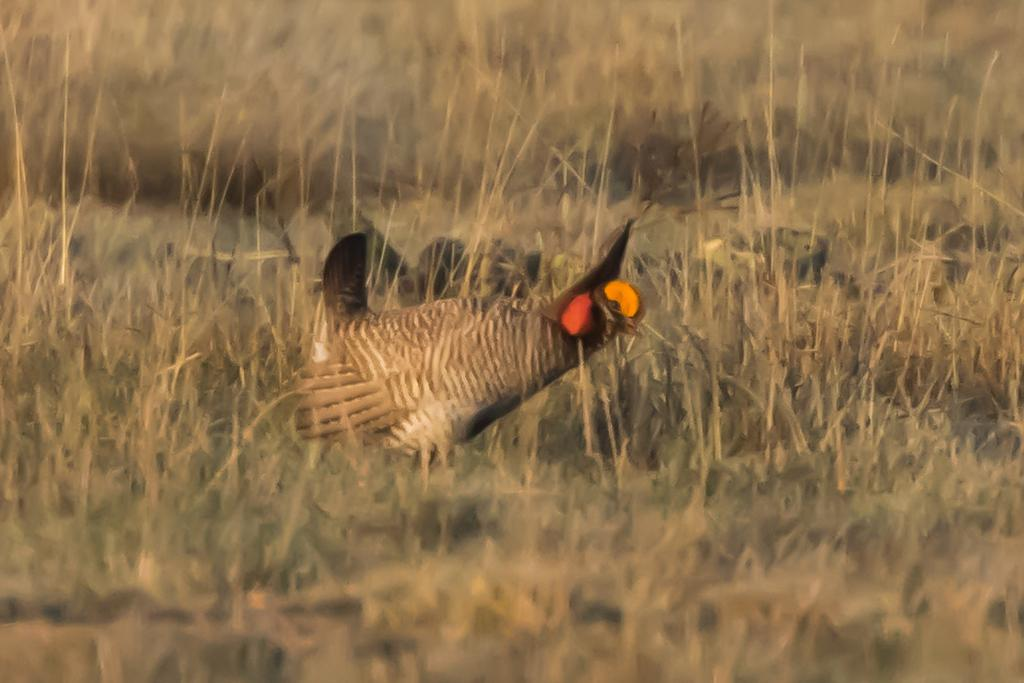What type of animal is in the image? There is a cock in the image. What is the cock standing on? The cock is on the surface of the grass. What type of pail is located next to the cock in the image? There is no pail present in the image. On which side of the cock is the clock located in the image? There is no clock present in the image. 